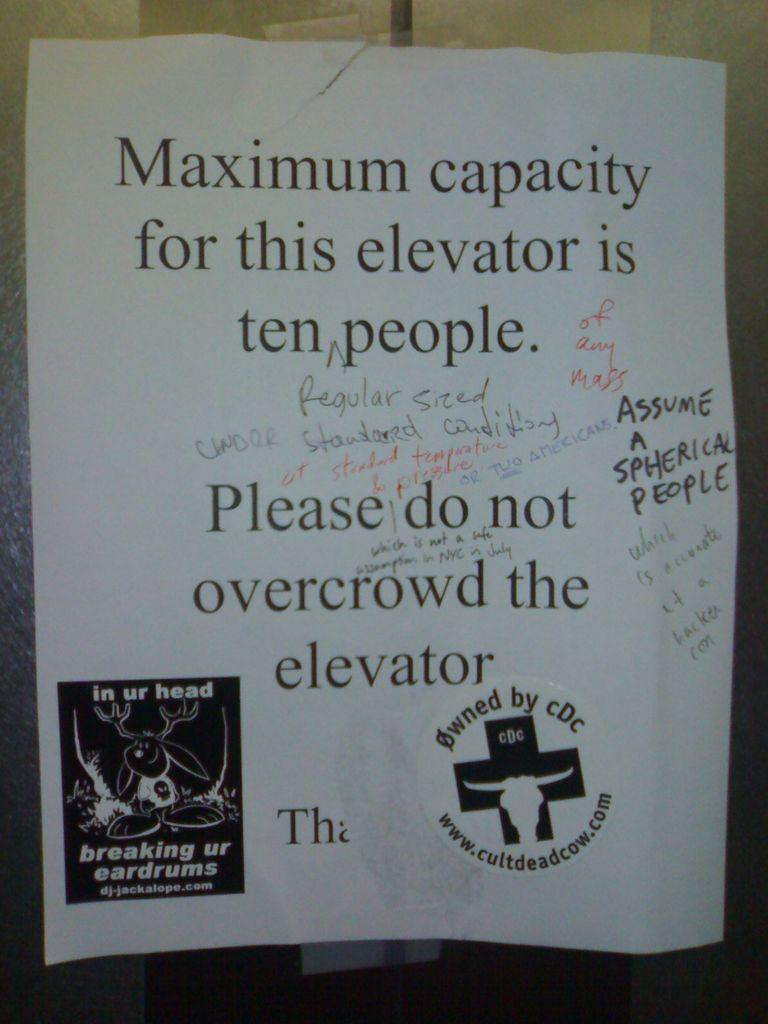What is the maximum capacity of the elevator?
Your answer should be compact. Ten people. Who is this owned by?
Provide a succinct answer. Cdc. 